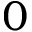Convert formula to latex. <formula><loc_0><loc_0><loc_500><loc_500>0</formula> 